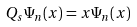Convert formula to latex. <formula><loc_0><loc_0><loc_500><loc_500>Q _ { s } \Psi _ { n } ( x ) = x \Psi _ { n } ( x )</formula> 